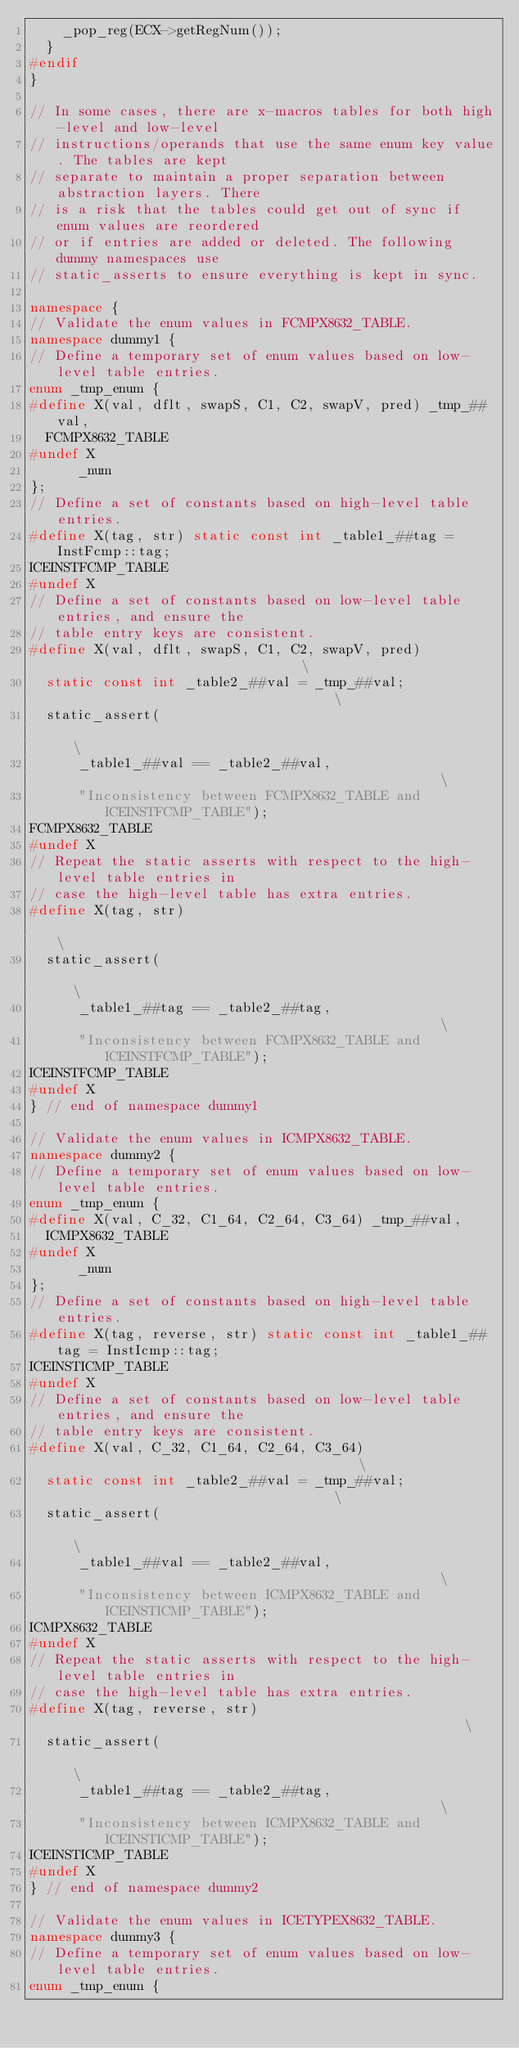<code> <loc_0><loc_0><loc_500><loc_500><_C++_>    _pop_reg(ECX->getRegNum());
  }
#endif
}

// In some cases, there are x-macros tables for both high-level and low-level
// instructions/operands that use the same enum key value. The tables are kept
// separate to maintain a proper separation between abstraction layers. There
// is a risk that the tables could get out of sync if enum values are reordered
// or if entries are added or deleted. The following dummy namespaces use
// static_asserts to ensure everything is kept in sync.

namespace {
// Validate the enum values in FCMPX8632_TABLE.
namespace dummy1 {
// Define a temporary set of enum values based on low-level table entries.
enum _tmp_enum {
#define X(val, dflt, swapS, C1, C2, swapV, pred) _tmp_##val,
  FCMPX8632_TABLE
#undef X
      _num
};
// Define a set of constants based on high-level table entries.
#define X(tag, str) static const int _table1_##tag = InstFcmp::tag;
ICEINSTFCMP_TABLE
#undef X
// Define a set of constants based on low-level table entries, and ensure the
// table entry keys are consistent.
#define X(val, dflt, swapS, C1, C2, swapV, pred)                               \
  static const int _table2_##val = _tmp_##val;                                 \
  static_assert(                                                               \
      _table1_##val == _table2_##val,                                          \
      "Inconsistency between FCMPX8632_TABLE and ICEINSTFCMP_TABLE");
FCMPX8632_TABLE
#undef X
// Repeat the static asserts with respect to the high-level table entries in
// case the high-level table has extra entries.
#define X(tag, str)                                                            \
  static_assert(                                                               \
      _table1_##tag == _table2_##tag,                                          \
      "Inconsistency between FCMPX8632_TABLE and ICEINSTFCMP_TABLE");
ICEINSTFCMP_TABLE
#undef X
} // end of namespace dummy1

// Validate the enum values in ICMPX8632_TABLE.
namespace dummy2 {
// Define a temporary set of enum values based on low-level table entries.
enum _tmp_enum {
#define X(val, C_32, C1_64, C2_64, C3_64) _tmp_##val,
  ICMPX8632_TABLE
#undef X
      _num
};
// Define a set of constants based on high-level table entries.
#define X(tag, reverse, str) static const int _table1_##tag = InstIcmp::tag;
ICEINSTICMP_TABLE
#undef X
// Define a set of constants based on low-level table entries, and ensure the
// table entry keys are consistent.
#define X(val, C_32, C1_64, C2_64, C3_64)                                      \
  static const int _table2_##val = _tmp_##val;                                 \
  static_assert(                                                               \
      _table1_##val == _table2_##val,                                          \
      "Inconsistency between ICMPX8632_TABLE and ICEINSTICMP_TABLE");
ICMPX8632_TABLE
#undef X
// Repeat the static asserts with respect to the high-level table entries in
// case the high-level table has extra entries.
#define X(tag, reverse, str)                                                   \
  static_assert(                                                               \
      _table1_##tag == _table2_##tag,                                          \
      "Inconsistency between ICMPX8632_TABLE and ICEINSTICMP_TABLE");
ICEINSTICMP_TABLE
#undef X
} // end of namespace dummy2

// Validate the enum values in ICETYPEX8632_TABLE.
namespace dummy3 {
// Define a temporary set of enum values based on low-level table entries.
enum _tmp_enum {</code> 